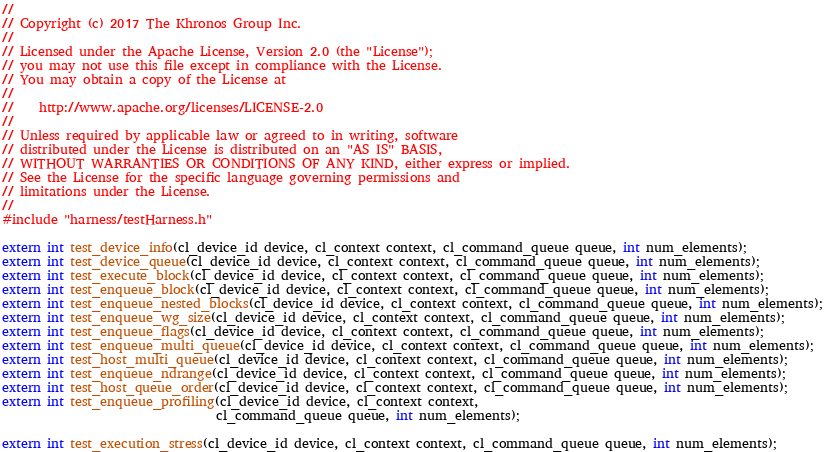Convert code to text. <code><loc_0><loc_0><loc_500><loc_500><_C_>//
// Copyright (c) 2017 The Khronos Group Inc.
// 
// Licensed under the Apache License, Version 2.0 (the "License");
// you may not use this file except in compliance with the License.
// You may obtain a copy of the License at
//
//    http://www.apache.org/licenses/LICENSE-2.0
//
// Unless required by applicable law or agreed to in writing, software
// distributed under the License is distributed on an "AS IS" BASIS,
// WITHOUT WARRANTIES OR CONDITIONS OF ANY KIND, either express or implied.
// See the License for the specific language governing permissions and
// limitations under the License.
//
#include "harness/testHarness.h"

extern int test_device_info(cl_device_id device, cl_context context, cl_command_queue queue, int num_elements);
extern int test_device_queue(cl_device_id device, cl_context context, cl_command_queue queue, int num_elements);
extern int test_execute_block(cl_device_id device, cl_context context, cl_command_queue queue, int num_elements);
extern int test_enqueue_block(cl_device_id device, cl_context context, cl_command_queue queue, int num_elements);
extern int test_enqueue_nested_blocks(cl_device_id device, cl_context context, cl_command_queue queue, int num_elements);
extern int test_enqueue_wg_size(cl_device_id device, cl_context context, cl_command_queue queue, int num_elements);
extern int test_enqueue_flags(cl_device_id device, cl_context context, cl_command_queue queue, int num_elements);
extern int test_enqueue_multi_queue(cl_device_id device, cl_context context, cl_command_queue queue, int num_elements);
extern int test_host_multi_queue(cl_device_id device, cl_context context, cl_command_queue queue, int num_elements);
extern int test_enqueue_ndrange(cl_device_id device, cl_context context, cl_command_queue queue, int num_elements);
extern int test_host_queue_order(cl_device_id device, cl_context context, cl_command_queue queue, int num_elements);
extern int test_enqueue_profiling(cl_device_id device, cl_context context,
                                  cl_command_queue queue, int num_elements);

extern int test_execution_stress(cl_device_id device, cl_context context, cl_command_queue queue, int num_elements);


</code> 